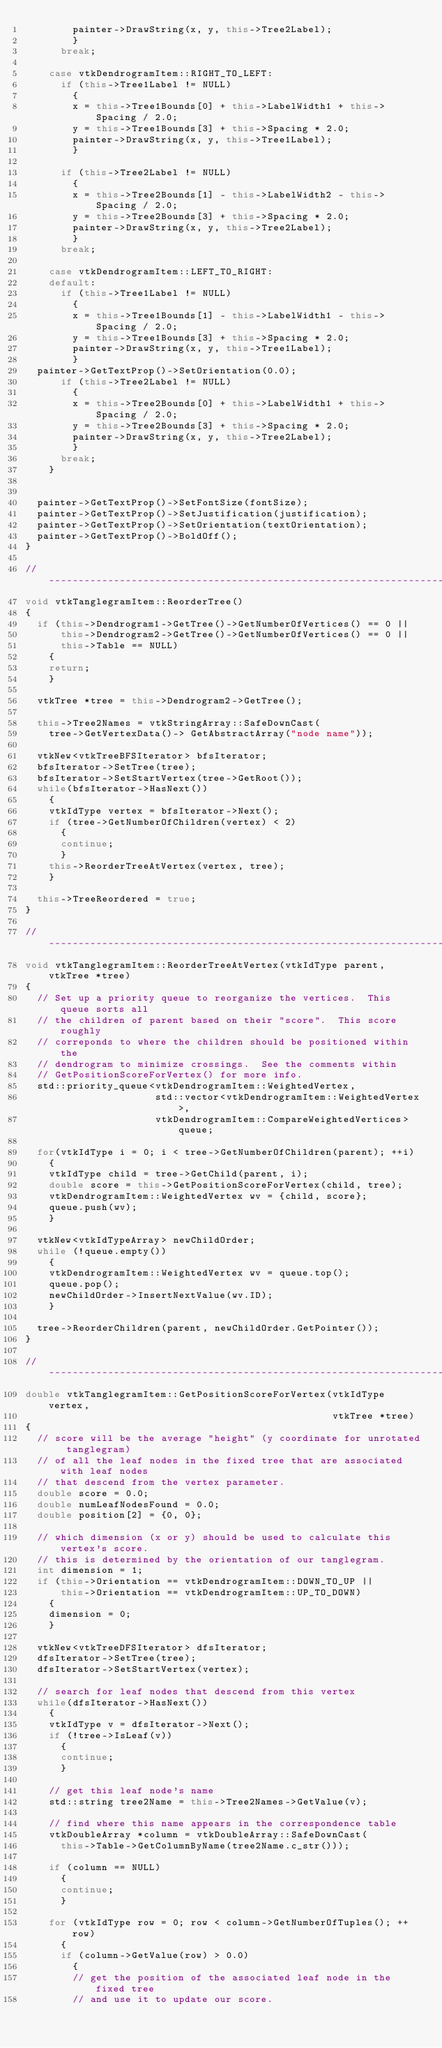<code> <loc_0><loc_0><loc_500><loc_500><_C++_>        painter->DrawString(x, y, this->Tree2Label);
        }
      break;

    case vtkDendrogramItem::RIGHT_TO_LEFT:
      if (this->Tree1Label != NULL)
        {
        x = this->Tree1Bounds[0] + this->LabelWidth1 + this->Spacing / 2.0;
        y = this->Tree1Bounds[3] + this->Spacing * 2.0;
        painter->DrawString(x, y, this->Tree1Label);
        }

      if (this->Tree2Label != NULL)
        {
        x = this->Tree2Bounds[1] - this->LabelWidth2 - this->Spacing / 2.0;
        y = this->Tree2Bounds[3] + this->Spacing * 2.0;
        painter->DrawString(x, y, this->Tree2Label);
        }
      break;

    case vtkDendrogramItem::LEFT_TO_RIGHT:
    default:
      if (this->Tree1Label != NULL)
        {
        x = this->Tree1Bounds[1] - this->LabelWidth1 - this->Spacing / 2.0;
        y = this->Tree1Bounds[3] + this->Spacing * 2.0;
        painter->DrawString(x, y, this->Tree1Label);
        }
  painter->GetTextProp()->SetOrientation(0.0);
      if (this->Tree2Label != NULL)
        {
        x = this->Tree2Bounds[0] + this->LabelWidth1 + this->Spacing / 2.0;
        y = this->Tree2Bounds[3] + this->Spacing * 2.0;
        painter->DrawString(x, y, this->Tree2Label);
        }
      break;
    }


  painter->GetTextProp()->SetFontSize(fontSize);
  painter->GetTextProp()->SetJustification(justification);
  painter->GetTextProp()->SetOrientation(textOrientation);
  painter->GetTextProp()->BoldOff();
}

//-----------------------------------------------------------------------------
void vtkTanglegramItem::ReorderTree()
{
  if (this->Dendrogram1->GetTree()->GetNumberOfVertices() == 0 ||
      this->Dendrogram2->GetTree()->GetNumberOfVertices() == 0 ||
      this->Table == NULL)
    {
    return;
    }

  vtkTree *tree = this->Dendrogram2->GetTree();

  this->Tree2Names = vtkStringArray::SafeDownCast(
    tree->GetVertexData()-> GetAbstractArray("node name"));

  vtkNew<vtkTreeBFSIterator> bfsIterator;
  bfsIterator->SetTree(tree);
  bfsIterator->SetStartVertex(tree->GetRoot());
  while(bfsIterator->HasNext())
    {
    vtkIdType vertex = bfsIterator->Next();
    if (tree->GetNumberOfChildren(vertex) < 2)
      {
      continue;
      }
    this->ReorderTreeAtVertex(vertex, tree);
    }

  this->TreeReordered = true;
}

//-----------------------------------------------------------------------------
void vtkTanglegramItem::ReorderTreeAtVertex(vtkIdType parent, vtkTree *tree)
{
  // Set up a priority queue to reorganize the vertices.  This queue sorts all
  // the children of parent based on their "score".  This score roughly
  // correponds to where the children should be positioned within the
  // dendrogram to minimize crossings.  See the comments within
  // GetPositionScoreForVertex() for more info.
  std::priority_queue<vtkDendrogramItem::WeightedVertex,
                      std::vector<vtkDendrogramItem::WeightedVertex>,
                      vtkDendrogramItem::CompareWeightedVertices> queue;

  for(vtkIdType i = 0; i < tree->GetNumberOfChildren(parent); ++i)
    {
    vtkIdType child = tree->GetChild(parent, i);
    double score = this->GetPositionScoreForVertex(child, tree);
    vtkDendrogramItem::WeightedVertex wv = {child, score};
    queue.push(wv);
    }

  vtkNew<vtkIdTypeArray> newChildOrder;
  while (!queue.empty())
    {
    vtkDendrogramItem::WeightedVertex wv = queue.top();
    queue.pop();
    newChildOrder->InsertNextValue(wv.ID);
    }

  tree->ReorderChildren(parent, newChildOrder.GetPointer());
}

//-----------------------------------------------------------------------------
double vtkTanglegramItem::GetPositionScoreForVertex(vtkIdType vertex,
                                                    vtkTree *tree)
{
  // score will be the average "height" (y coordinate for unrotated tanglegram)
  // of all the leaf nodes in the fixed tree that are associated with leaf nodes
  // that descend from the vertex parameter.
  double score = 0.0;
  double numLeafNodesFound = 0.0;
  double position[2] = {0, 0};

  // which dimension (x or y) should be used to calculate this vertex's score.
  // this is determined by the orientation of our tanglegram.
  int dimension = 1;
  if (this->Orientation == vtkDendrogramItem::DOWN_TO_UP ||
      this->Orientation == vtkDendrogramItem::UP_TO_DOWN)
    {
    dimension = 0;
    }

  vtkNew<vtkTreeDFSIterator> dfsIterator;
  dfsIterator->SetTree(tree);
  dfsIterator->SetStartVertex(vertex);

  // search for leaf nodes that descend from this vertex
  while(dfsIterator->HasNext())
    {
    vtkIdType v = dfsIterator->Next();
    if (!tree->IsLeaf(v))
      {
      continue;
      }

    // get this leaf node's name
    std::string tree2Name = this->Tree2Names->GetValue(v);

    // find where this name appears in the correspondence table
    vtkDoubleArray *column = vtkDoubleArray::SafeDownCast(
      this->Table->GetColumnByName(tree2Name.c_str()));

    if (column == NULL)
      {
      continue;
      }

    for (vtkIdType row = 0; row < column->GetNumberOfTuples(); ++row)
      {
      if (column->GetValue(row) > 0.0)
        {
        // get the position of the associated leaf node in the fixed tree
        // and use it to update our score.</code> 